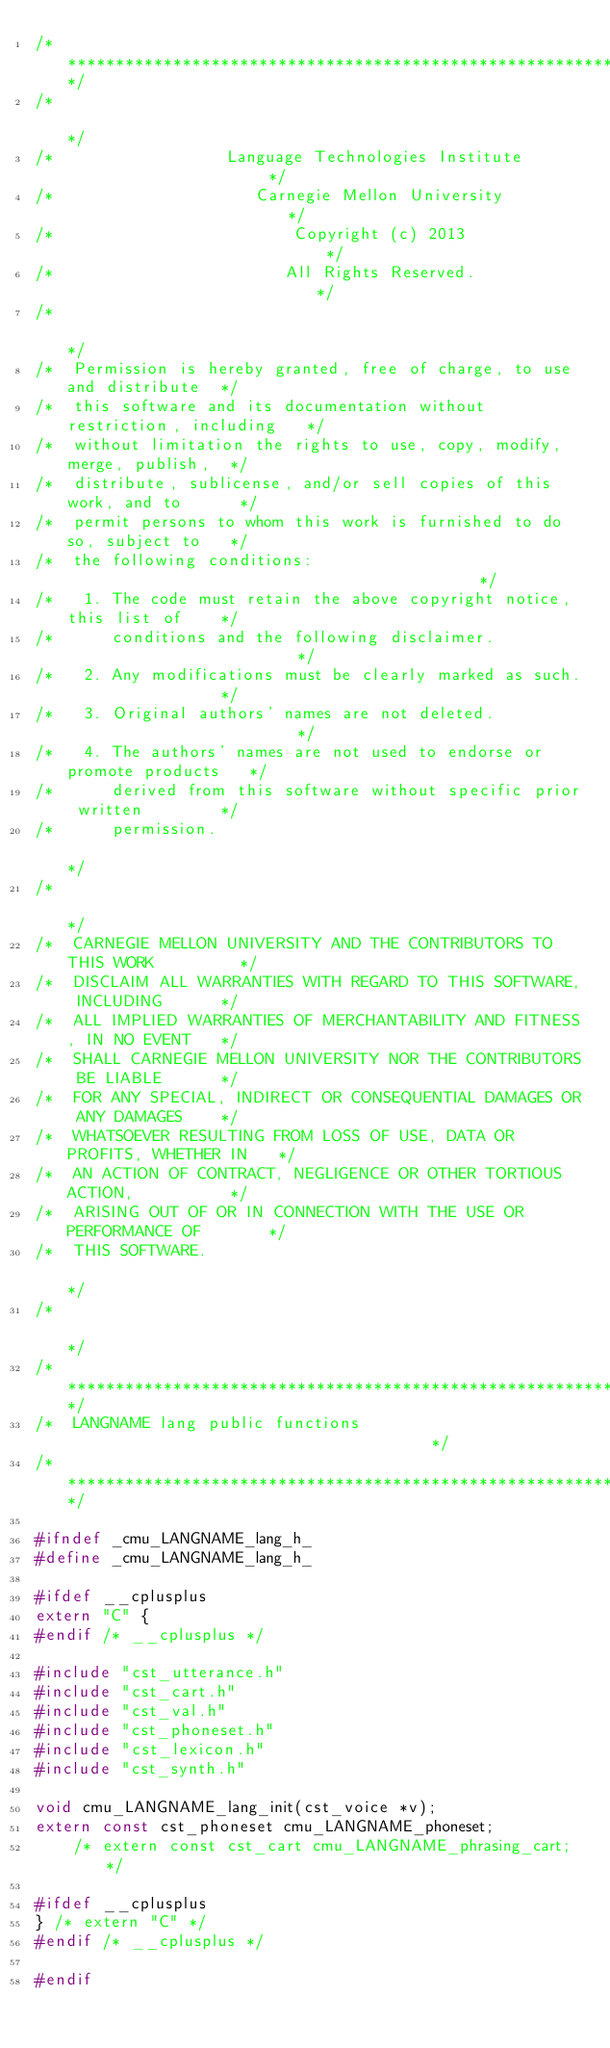Convert code to text. <code><loc_0><loc_0><loc_500><loc_500><_C_>/*************************************************************************/
/*                                                                       */
/*                  Language Technologies Institute                      */
/*                     Carnegie Mellon University                        */
/*                         Copyright (c) 2013                            */
/*                        All Rights Reserved.                           */
/*                                                                       */
/*  Permission is hereby granted, free of charge, to use and distribute  */
/*  this software and its documentation without restriction, including   */
/*  without limitation the rights to use, copy, modify, merge, publish,  */
/*  distribute, sublicense, and/or sell copies of this work, and to      */
/*  permit persons to whom this work is furnished to do so, subject to   */
/*  the following conditions:                                            */
/*   1. The code must retain the above copyright notice, this list of    */
/*      conditions and the following disclaimer.                         */
/*   2. Any modifications must be clearly marked as such.                */
/*   3. Original authors' names are not deleted.                         */
/*   4. The authors' names are not used to endorse or promote products   */
/*      derived from this software without specific prior written        */
/*      permission.                                                      */
/*                                                                       */
/*  CARNEGIE MELLON UNIVERSITY AND THE CONTRIBUTORS TO THIS WORK         */
/*  DISCLAIM ALL WARRANTIES WITH REGARD TO THIS SOFTWARE, INCLUDING      */
/*  ALL IMPLIED WARRANTIES OF MERCHANTABILITY AND FITNESS, IN NO EVENT   */
/*  SHALL CARNEGIE MELLON UNIVERSITY NOR THE CONTRIBUTORS BE LIABLE      */
/*  FOR ANY SPECIAL, INDIRECT OR CONSEQUENTIAL DAMAGES OR ANY DAMAGES    */
/*  WHATSOEVER RESULTING FROM LOSS OF USE, DATA OR PROFITS, WHETHER IN   */
/*  AN ACTION OF CONTRACT, NEGLIGENCE OR OTHER TORTIOUS ACTION,          */
/*  ARISING OUT OF OR IN CONNECTION WITH THE USE OR PERFORMANCE OF       */
/*  THIS SOFTWARE.                                                       */
/*                                                                       */
/*************************************************************************/
/*  LANGNAME lang public functions                                       */
/*************************************************************************/

#ifndef _cmu_LANGNAME_lang_h_
#define _cmu_LANGNAME_lang_h_

#ifdef __cplusplus
extern "C" {
#endif /* __cplusplus */

#include "cst_utterance.h"
#include "cst_cart.h"
#include "cst_val.h"
#include "cst_phoneset.h"
#include "cst_lexicon.h"
#include "cst_synth.h"

void cmu_LANGNAME_lang_init(cst_voice *v);
extern const cst_phoneset cmu_LANGNAME_phoneset;
    /* extern const cst_cart cmu_LANGNAME_phrasing_cart; */

#ifdef __cplusplus
} /* extern "C" */
#endif /* __cplusplus */

#endif

</code> 